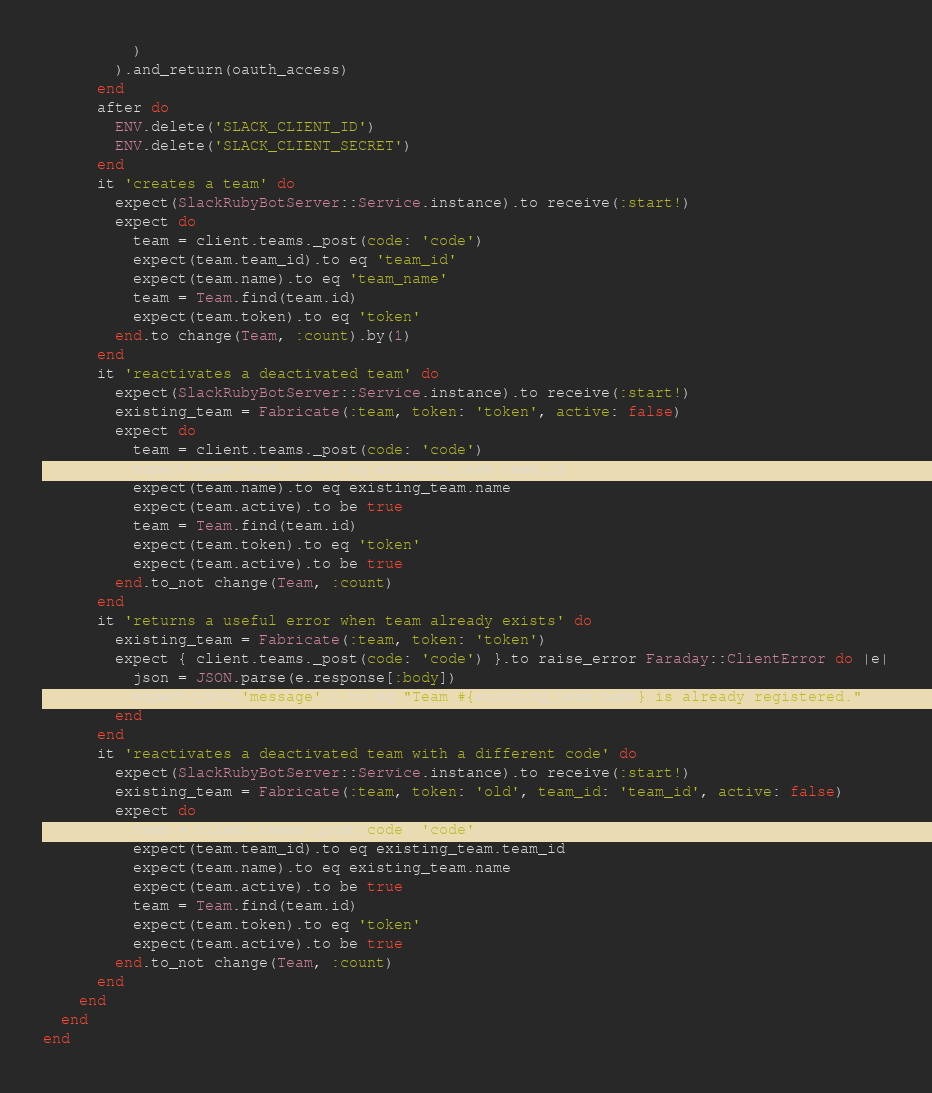Convert code to text. <code><loc_0><loc_0><loc_500><loc_500><_Ruby_>          )
        ).and_return(oauth_access)
      end
      after do
        ENV.delete('SLACK_CLIENT_ID')
        ENV.delete('SLACK_CLIENT_SECRET')
      end
      it 'creates a team' do
        expect(SlackRubyBotServer::Service.instance).to receive(:start!)
        expect do
          team = client.teams._post(code: 'code')
          expect(team.team_id).to eq 'team_id'
          expect(team.name).to eq 'team_name'
          team = Team.find(team.id)
          expect(team.token).to eq 'token'
        end.to change(Team, :count).by(1)
      end
      it 'reactivates a deactivated team' do
        expect(SlackRubyBotServer::Service.instance).to receive(:start!)
        existing_team = Fabricate(:team, token: 'token', active: false)
        expect do
          team = client.teams._post(code: 'code')
          expect(team.team_id).to eq existing_team.team_id
          expect(team.name).to eq existing_team.name
          expect(team.active).to be true
          team = Team.find(team.id)
          expect(team.token).to eq 'token'
          expect(team.active).to be true
        end.to_not change(Team, :count)
      end
      it 'returns a useful error when team already exists' do
        existing_team = Fabricate(:team, token: 'token')
        expect { client.teams._post(code: 'code') }.to raise_error Faraday::ClientError do |e|
          json = JSON.parse(e.response[:body])
          expect(json['message']).to eq "Team #{existing_team.name} is already registered."
        end
      end
      it 'reactivates a deactivated team with a different code' do
        expect(SlackRubyBotServer::Service.instance).to receive(:start!)
        existing_team = Fabricate(:team, token: 'old', team_id: 'team_id', active: false)
        expect do
          team = client.teams._post(code: 'code')
          expect(team.team_id).to eq existing_team.team_id
          expect(team.name).to eq existing_team.name
          expect(team.active).to be true
          team = Team.find(team.id)
          expect(team.token).to eq 'token'
          expect(team.active).to be true
        end.to_not change(Team, :count)
      end
    end
  end
end
</code> 